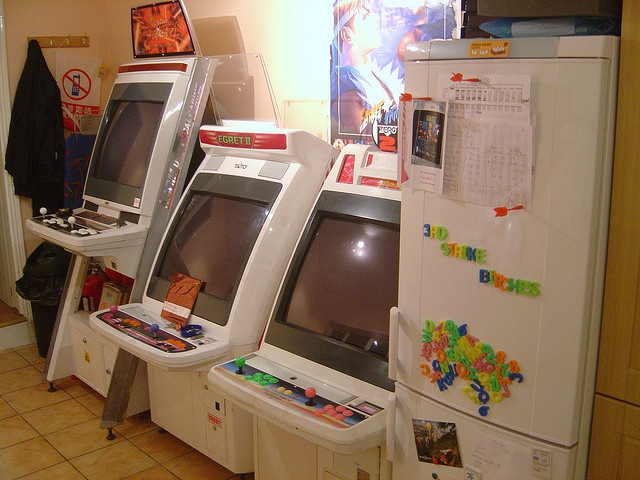Describe the objects in this image and their specific colors. I can see refrigerator in gray, tan, darkgray, and olive tones, tv in gray, maroon, and black tones, tv in gray, maroon, and black tones, and tv in gray, black, maroon, and brown tones in this image. 